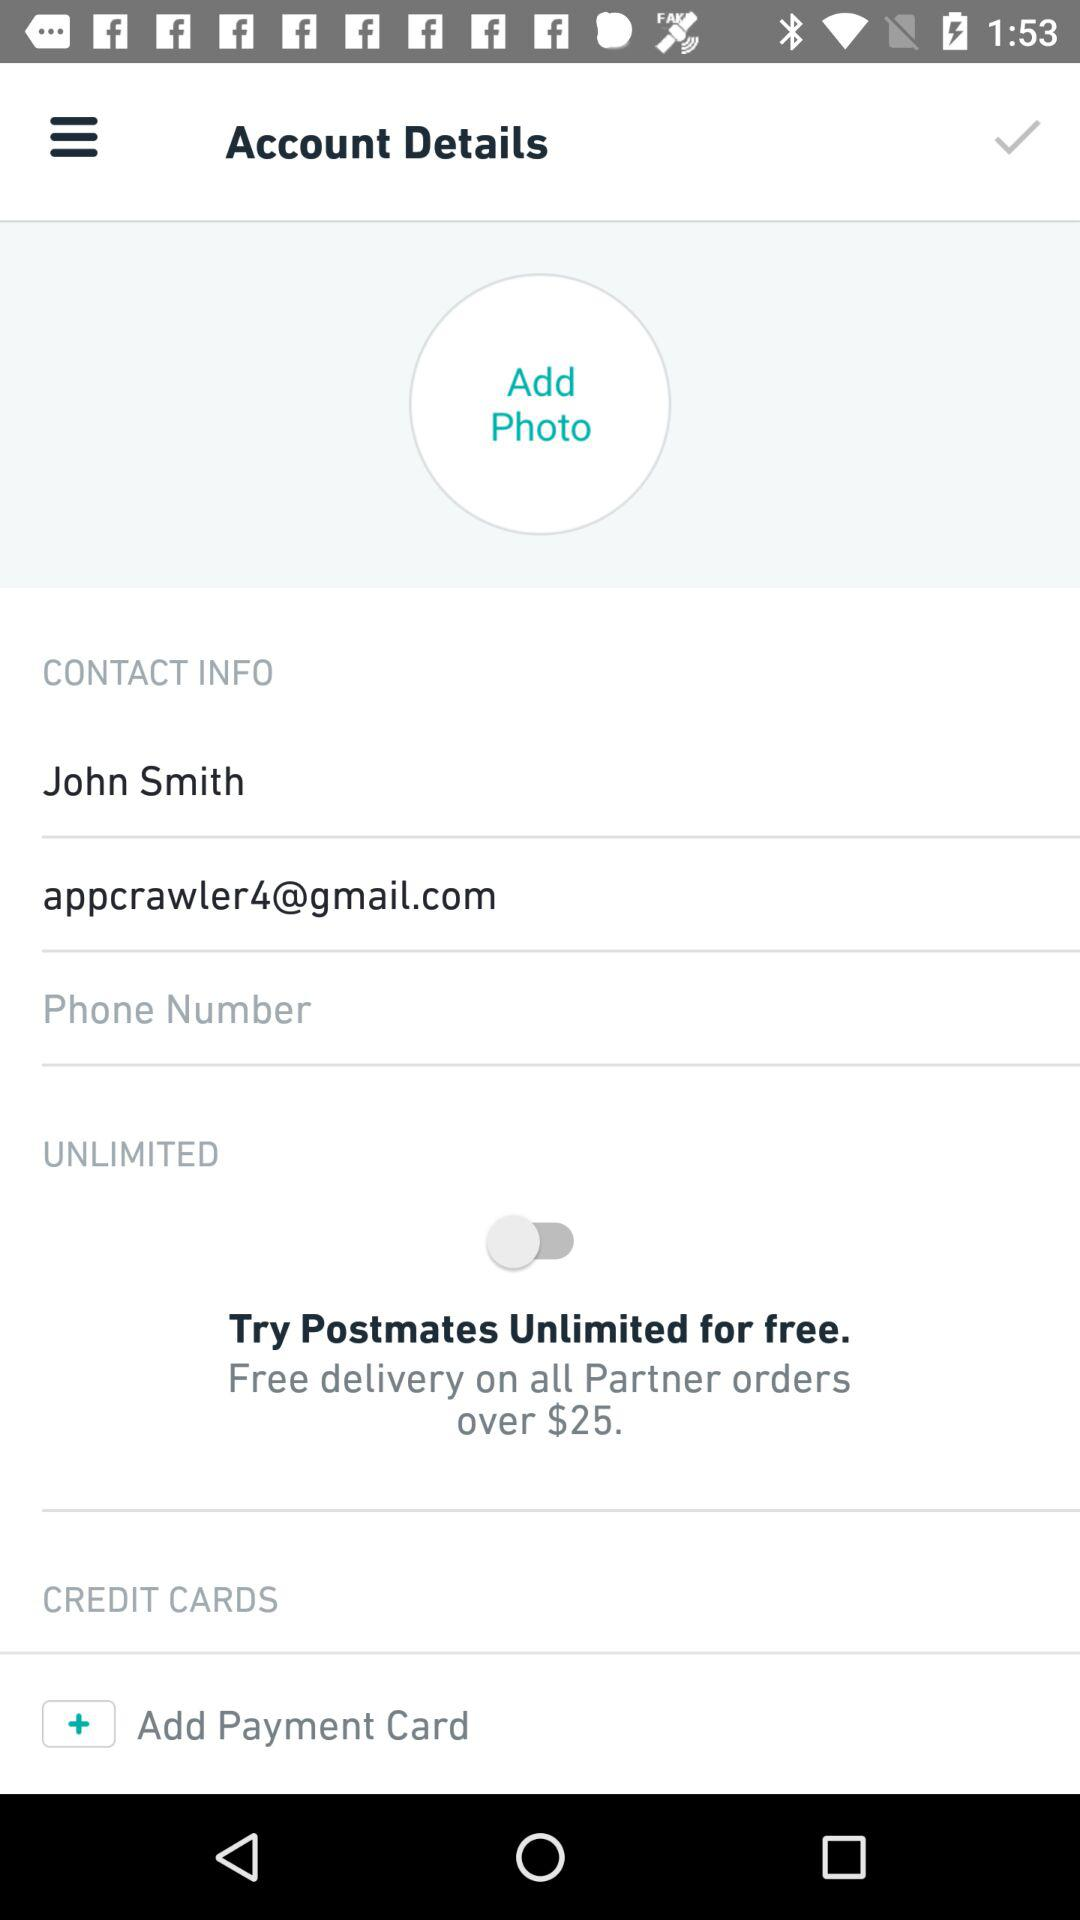Over what amount of orders will the delivery is free? The delivery will be free over $25. 